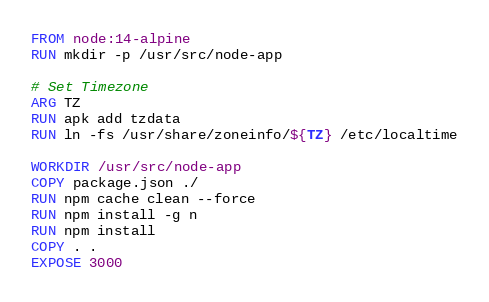<code> <loc_0><loc_0><loc_500><loc_500><_Dockerfile_>FROM node:14-alpine
RUN mkdir -p /usr/src/node-app

# Set Timezone
ARG TZ
RUN apk add tzdata 
RUN ln -fs /usr/share/zoneinfo/${TZ} /etc/localtime

WORKDIR /usr/src/node-app
COPY package.json ./
RUN npm cache clean --force
RUN npm install -g n
RUN npm install
COPY . .
EXPOSE 3000
</code> 